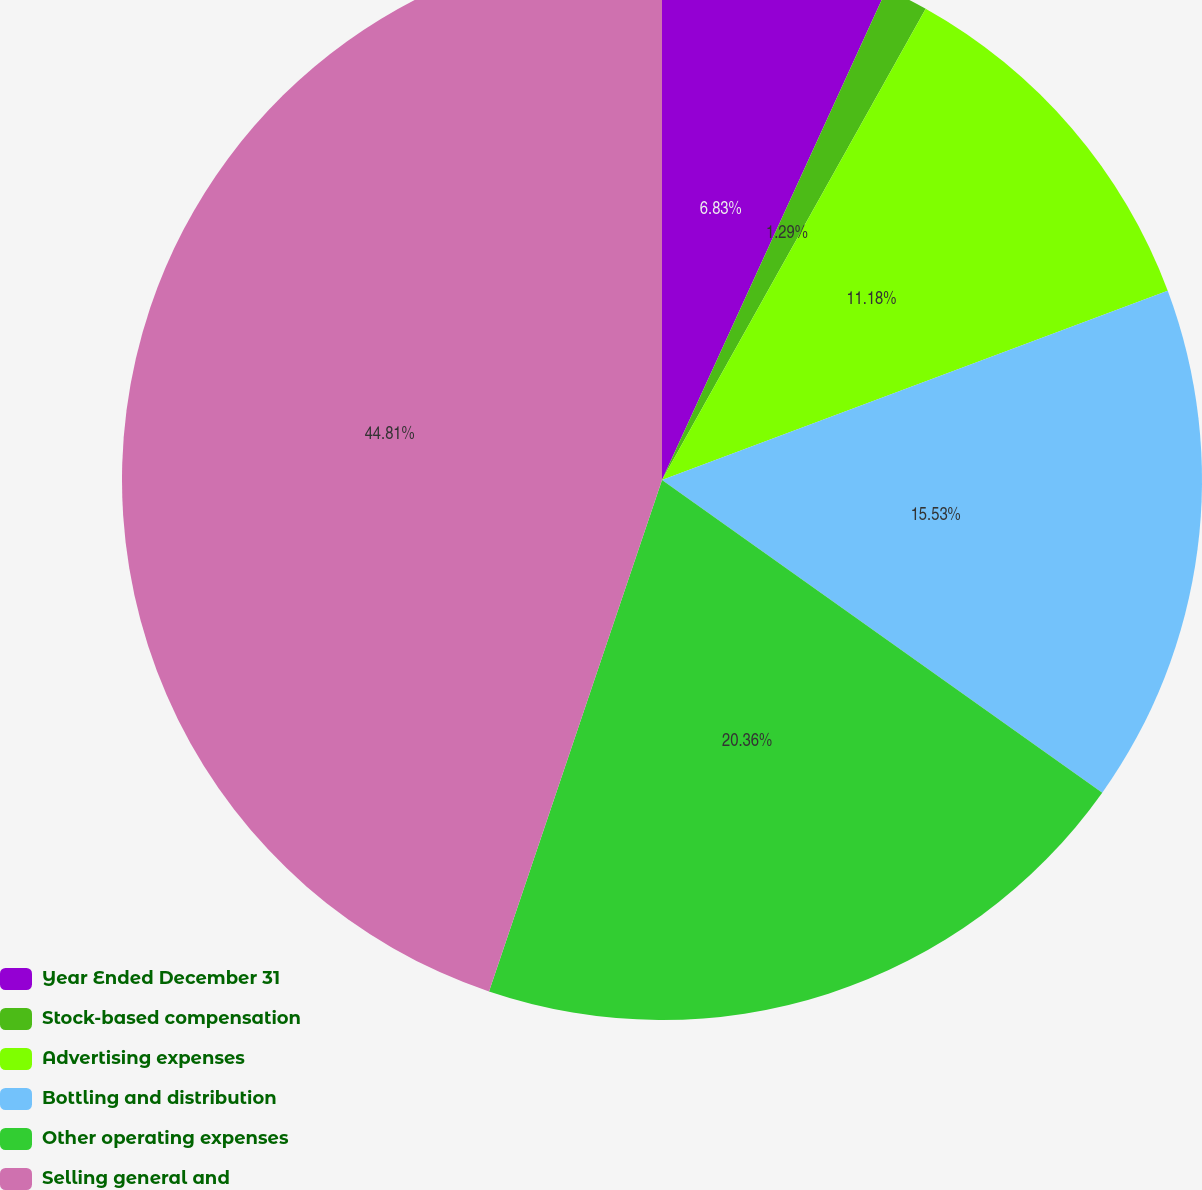<chart> <loc_0><loc_0><loc_500><loc_500><pie_chart><fcel>Year Ended December 31<fcel>Stock-based compensation<fcel>Advertising expenses<fcel>Bottling and distribution<fcel>Other operating expenses<fcel>Selling general and<nl><fcel>6.83%<fcel>1.29%<fcel>11.18%<fcel>15.53%<fcel>20.36%<fcel>44.81%<nl></chart> 